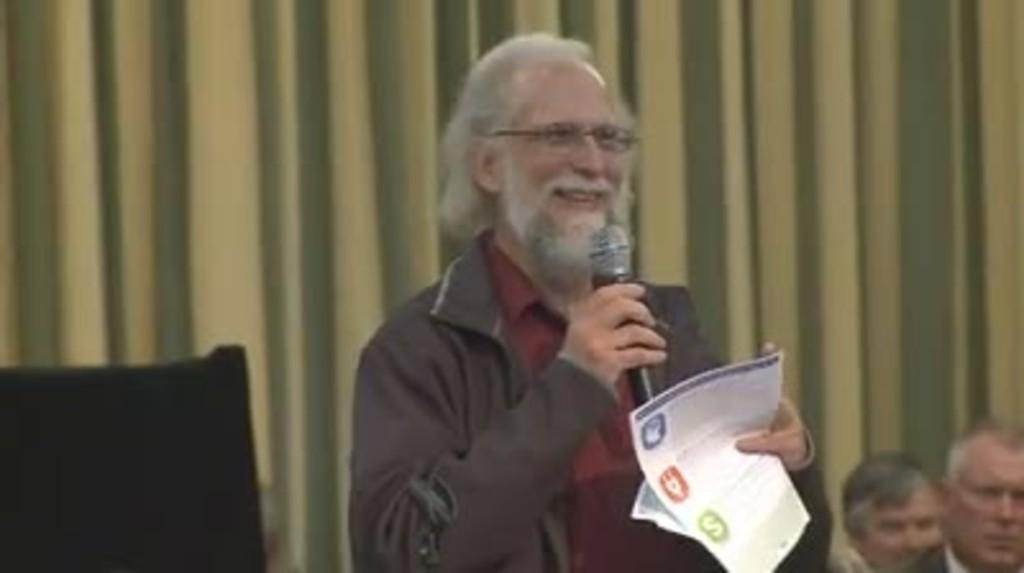Who is the main subject in the image? There is a person in the center of the image. What is the person holding in the image? The person is holding a mic and paper. What can be seen in the background of the image? There are chairpersons and a curtain in the background of the image. What type of lunch is being served to the chairpersons in the image? There is no lunch visible in the image, and it does not mention any food being served. 